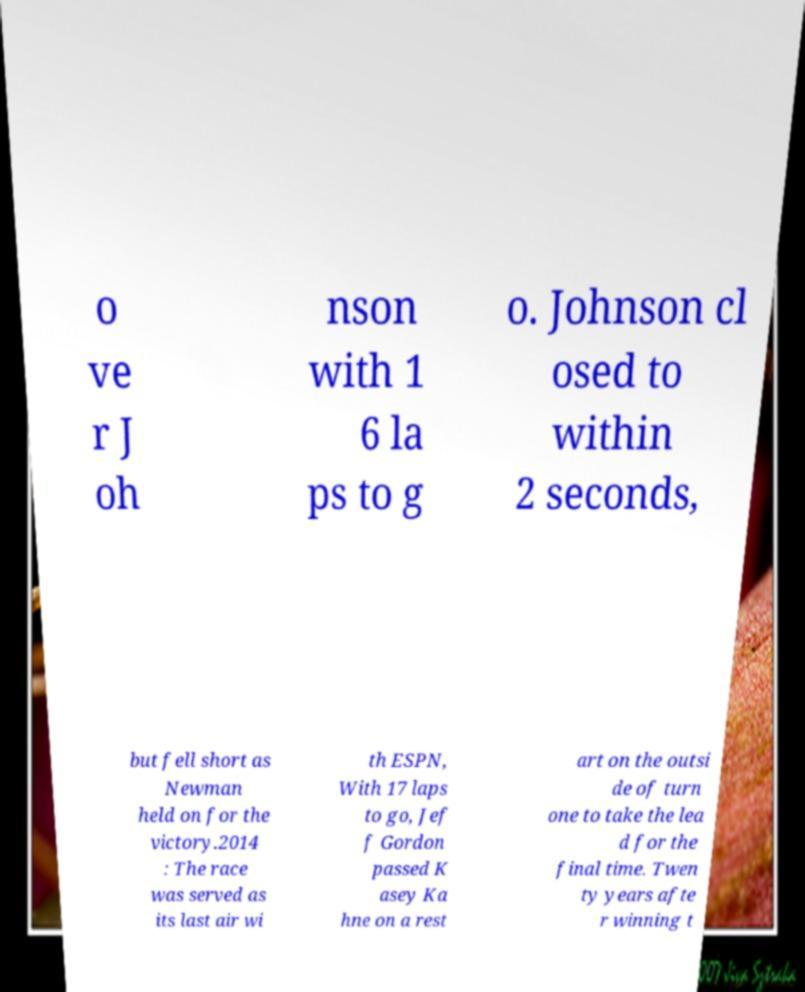What messages or text are displayed in this image? I need them in a readable, typed format. o ve r J oh nson with 1 6 la ps to g o. Johnson cl osed to within 2 seconds, but fell short as Newman held on for the victory.2014 : The race was served as its last air wi th ESPN, With 17 laps to go, Jef f Gordon passed K asey Ka hne on a rest art on the outsi de of turn one to take the lea d for the final time. Twen ty years afte r winning t 